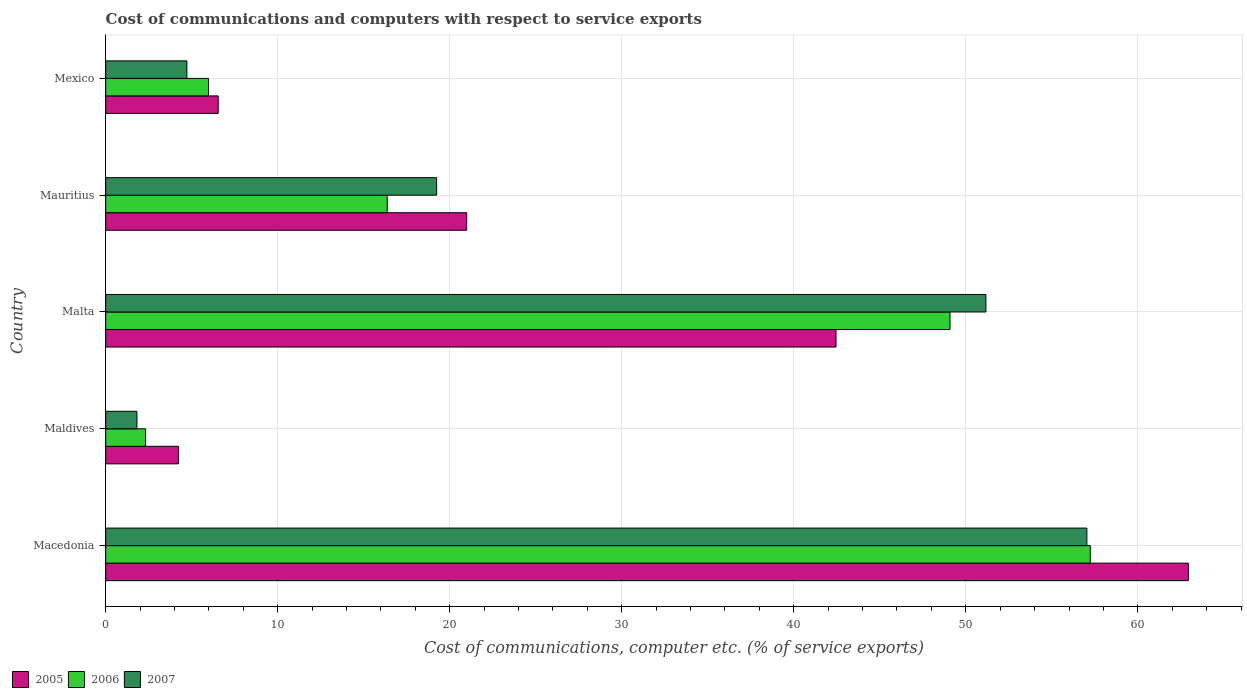How many different coloured bars are there?
Ensure brevity in your answer.  3. How many groups of bars are there?
Offer a very short reply. 5. Are the number of bars on each tick of the Y-axis equal?
Your answer should be very brief. Yes. How many bars are there on the 5th tick from the top?
Make the answer very short. 3. How many bars are there on the 1st tick from the bottom?
Offer a terse response. 3. What is the label of the 2nd group of bars from the top?
Offer a very short reply. Mauritius. In how many cases, is the number of bars for a given country not equal to the number of legend labels?
Make the answer very short. 0. What is the cost of communications and computers in 2006 in Malta?
Give a very brief answer. 49.08. Across all countries, what is the maximum cost of communications and computers in 2007?
Your answer should be very brief. 57.04. Across all countries, what is the minimum cost of communications and computers in 2006?
Your answer should be compact. 2.32. In which country was the cost of communications and computers in 2006 maximum?
Provide a short and direct response. Macedonia. In which country was the cost of communications and computers in 2007 minimum?
Offer a terse response. Maldives. What is the total cost of communications and computers in 2007 in the graph?
Offer a terse response. 133.98. What is the difference between the cost of communications and computers in 2007 in Macedonia and that in Maldives?
Provide a short and direct response. 55.22. What is the difference between the cost of communications and computers in 2007 in Maldives and the cost of communications and computers in 2006 in Mexico?
Your answer should be very brief. -4.16. What is the average cost of communications and computers in 2007 per country?
Your answer should be compact. 26.8. What is the difference between the cost of communications and computers in 2005 and cost of communications and computers in 2006 in Mauritius?
Provide a short and direct response. 4.62. In how many countries, is the cost of communications and computers in 2005 greater than 6 %?
Provide a short and direct response. 4. What is the ratio of the cost of communications and computers in 2007 in Malta to that in Mexico?
Your response must be concise. 10.84. What is the difference between the highest and the second highest cost of communications and computers in 2007?
Provide a short and direct response. 5.87. What is the difference between the highest and the lowest cost of communications and computers in 2005?
Offer a very short reply. 58.71. Is the sum of the cost of communications and computers in 2005 in Maldives and Mauritius greater than the maximum cost of communications and computers in 2007 across all countries?
Give a very brief answer. No. What does the 1st bar from the bottom in Macedonia represents?
Provide a succinct answer. 2005. Are all the bars in the graph horizontal?
Provide a succinct answer. Yes. Does the graph contain any zero values?
Offer a terse response. No. How many legend labels are there?
Your answer should be compact. 3. How are the legend labels stacked?
Provide a succinct answer. Horizontal. What is the title of the graph?
Provide a short and direct response. Cost of communications and computers with respect to service exports. What is the label or title of the X-axis?
Your answer should be compact. Cost of communications, computer etc. (% of service exports). What is the Cost of communications, computer etc. (% of service exports) in 2005 in Macedonia?
Offer a terse response. 62.94. What is the Cost of communications, computer etc. (% of service exports) in 2006 in Macedonia?
Provide a short and direct response. 57.24. What is the Cost of communications, computer etc. (% of service exports) of 2007 in Macedonia?
Offer a terse response. 57.04. What is the Cost of communications, computer etc. (% of service exports) of 2005 in Maldives?
Offer a very short reply. 4.23. What is the Cost of communications, computer etc. (% of service exports) of 2006 in Maldives?
Your response must be concise. 2.32. What is the Cost of communications, computer etc. (% of service exports) in 2007 in Maldives?
Give a very brief answer. 1.82. What is the Cost of communications, computer etc. (% of service exports) of 2005 in Malta?
Give a very brief answer. 42.46. What is the Cost of communications, computer etc. (% of service exports) in 2006 in Malta?
Offer a very short reply. 49.08. What is the Cost of communications, computer etc. (% of service exports) in 2007 in Malta?
Make the answer very short. 51.17. What is the Cost of communications, computer etc. (% of service exports) in 2005 in Mauritius?
Your response must be concise. 20.99. What is the Cost of communications, computer etc. (% of service exports) of 2006 in Mauritius?
Ensure brevity in your answer.  16.37. What is the Cost of communications, computer etc. (% of service exports) of 2007 in Mauritius?
Keep it short and to the point. 19.24. What is the Cost of communications, computer etc. (% of service exports) in 2005 in Mexico?
Provide a succinct answer. 6.54. What is the Cost of communications, computer etc. (% of service exports) of 2006 in Mexico?
Provide a succinct answer. 5.98. What is the Cost of communications, computer etc. (% of service exports) in 2007 in Mexico?
Offer a terse response. 4.72. Across all countries, what is the maximum Cost of communications, computer etc. (% of service exports) in 2005?
Your answer should be compact. 62.94. Across all countries, what is the maximum Cost of communications, computer etc. (% of service exports) of 2006?
Make the answer very short. 57.24. Across all countries, what is the maximum Cost of communications, computer etc. (% of service exports) of 2007?
Make the answer very short. 57.04. Across all countries, what is the minimum Cost of communications, computer etc. (% of service exports) of 2005?
Keep it short and to the point. 4.23. Across all countries, what is the minimum Cost of communications, computer etc. (% of service exports) of 2006?
Your answer should be very brief. 2.32. Across all countries, what is the minimum Cost of communications, computer etc. (% of service exports) in 2007?
Offer a terse response. 1.82. What is the total Cost of communications, computer etc. (% of service exports) of 2005 in the graph?
Your answer should be very brief. 137.15. What is the total Cost of communications, computer etc. (% of service exports) in 2006 in the graph?
Make the answer very short. 130.98. What is the total Cost of communications, computer etc. (% of service exports) of 2007 in the graph?
Give a very brief answer. 133.98. What is the difference between the Cost of communications, computer etc. (% of service exports) in 2005 in Macedonia and that in Maldives?
Offer a very short reply. 58.71. What is the difference between the Cost of communications, computer etc. (% of service exports) in 2006 in Macedonia and that in Maldives?
Provide a short and direct response. 54.92. What is the difference between the Cost of communications, computer etc. (% of service exports) in 2007 in Macedonia and that in Maldives?
Provide a short and direct response. 55.22. What is the difference between the Cost of communications, computer etc. (% of service exports) in 2005 in Macedonia and that in Malta?
Offer a very short reply. 20.48. What is the difference between the Cost of communications, computer etc. (% of service exports) in 2006 in Macedonia and that in Malta?
Give a very brief answer. 8.15. What is the difference between the Cost of communications, computer etc. (% of service exports) in 2007 in Macedonia and that in Malta?
Your answer should be compact. 5.87. What is the difference between the Cost of communications, computer etc. (% of service exports) in 2005 in Macedonia and that in Mauritius?
Keep it short and to the point. 41.95. What is the difference between the Cost of communications, computer etc. (% of service exports) of 2006 in Macedonia and that in Mauritius?
Offer a very short reply. 40.87. What is the difference between the Cost of communications, computer etc. (% of service exports) in 2007 in Macedonia and that in Mauritius?
Your answer should be compact. 37.8. What is the difference between the Cost of communications, computer etc. (% of service exports) of 2005 in Macedonia and that in Mexico?
Offer a very short reply. 56.4. What is the difference between the Cost of communications, computer etc. (% of service exports) of 2006 in Macedonia and that in Mexico?
Offer a very short reply. 51.26. What is the difference between the Cost of communications, computer etc. (% of service exports) of 2007 in Macedonia and that in Mexico?
Your response must be concise. 52.32. What is the difference between the Cost of communications, computer etc. (% of service exports) of 2005 in Maldives and that in Malta?
Offer a very short reply. -38.23. What is the difference between the Cost of communications, computer etc. (% of service exports) in 2006 in Maldives and that in Malta?
Offer a terse response. -46.77. What is the difference between the Cost of communications, computer etc. (% of service exports) of 2007 in Maldives and that in Malta?
Give a very brief answer. -49.35. What is the difference between the Cost of communications, computer etc. (% of service exports) of 2005 in Maldives and that in Mauritius?
Provide a succinct answer. -16.76. What is the difference between the Cost of communications, computer etc. (% of service exports) of 2006 in Maldives and that in Mauritius?
Provide a short and direct response. -14.05. What is the difference between the Cost of communications, computer etc. (% of service exports) in 2007 in Maldives and that in Mauritius?
Offer a very short reply. -17.42. What is the difference between the Cost of communications, computer etc. (% of service exports) of 2005 in Maldives and that in Mexico?
Ensure brevity in your answer.  -2.31. What is the difference between the Cost of communications, computer etc. (% of service exports) in 2006 in Maldives and that in Mexico?
Ensure brevity in your answer.  -3.66. What is the difference between the Cost of communications, computer etc. (% of service exports) of 2007 in Maldives and that in Mexico?
Your answer should be very brief. -2.9. What is the difference between the Cost of communications, computer etc. (% of service exports) in 2005 in Malta and that in Mauritius?
Give a very brief answer. 21.47. What is the difference between the Cost of communications, computer etc. (% of service exports) in 2006 in Malta and that in Mauritius?
Give a very brief answer. 32.72. What is the difference between the Cost of communications, computer etc. (% of service exports) in 2007 in Malta and that in Mauritius?
Your answer should be very brief. 31.93. What is the difference between the Cost of communications, computer etc. (% of service exports) in 2005 in Malta and that in Mexico?
Your response must be concise. 35.92. What is the difference between the Cost of communications, computer etc. (% of service exports) of 2006 in Malta and that in Mexico?
Give a very brief answer. 43.11. What is the difference between the Cost of communications, computer etc. (% of service exports) of 2007 in Malta and that in Mexico?
Provide a succinct answer. 46.45. What is the difference between the Cost of communications, computer etc. (% of service exports) in 2005 in Mauritius and that in Mexico?
Your answer should be compact. 14.45. What is the difference between the Cost of communications, computer etc. (% of service exports) of 2006 in Mauritius and that in Mexico?
Offer a very short reply. 10.39. What is the difference between the Cost of communications, computer etc. (% of service exports) in 2007 in Mauritius and that in Mexico?
Make the answer very short. 14.52. What is the difference between the Cost of communications, computer etc. (% of service exports) of 2005 in Macedonia and the Cost of communications, computer etc. (% of service exports) of 2006 in Maldives?
Provide a succinct answer. 60.62. What is the difference between the Cost of communications, computer etc. (% of service exports) in 2005 in Macedonia and the Cost of communications, computer etc. (% of service exports) in 2007 in Maldives?
Ensure brevity in your answer.  61.12. What is the difference between the Cost of communications, computer etc. (% of service exports) of 2006 in Macedonia and the Cost of communications, computer etc. (% of service exports) of 2007 in Maldives?
Ensure brevity in your answer.  55.42. What is the difference between the Cost of communications, computer etc. (% of service exports) of 2005 in Macedonia and the Cost of communications, computer etc. (% of service exports) of 2006 in Malta?
Your answer should be compact. 13.86. What is the difference between the Cost of communications, computer etc. (% of service exports) of 2005 in Macedonia and the Cost of communications, computer etc. (% of service exports) of 2007 in Malta?
Ensure brevity in your answer.  11.77. What is the difference between the Cost of communications, computer etc. (% of service exports) of 2006 in Macedonia and the Cost of communications, computer etc. (% of service exports) of 2007 in Malta?
Your answer should be very brief. 6.07. What is the difference between the Cost of communications, computer etc. (% of service exports) in 2005 in Macedonia and the Cost of communications, computer etc. (% of service exports) in 2006 in Mauritius?
Offer a very short reply. 46.57. What is the difference between the Cost of communications, computer etc. (% of service exports) in 2005 in Macedonia and the Cost of communications, computer etc. (% of service exports) in 2007 in Mauritius?
Provide a succinct answer. 43.7. What is the difference between the Cost of communications, computer etc. (% of service exports) of 2006 in Macedonia and the Cost of communications, computer etc. (% of service exports) of 2007 in Mauritius?
Make the answer very short. 38. What is the difference between the Cost of communications, computer etc. (% of service exports) in 2005 in Macedonia and the Cost of communications, computer etc. (% of service exports) in 2006 in Mexico?
Provide a short and direct response. 56.96. What is the difference between the Cost of communications, computer etc. (% of service exports) in 2005 in Macedonia and the Cost of communications, computer etc. (% of service exports) in 2007 in Mexico?
Make the answer very short. 58.22. What is the difference between the Cost of communications, computer etc. (% of service exports) of 2006 in Macedonia and the Cost of communications, computer etc. (% of service exports) of 2007 in Mexico?
Provide a short and direct response. 52.52. What is the difference between the Cost of communications, computer etc. (% of service exports) in 2005 in Maldives and the Cost of communications, computer etc. (% of service exports) in 2006 in Malta?
Your response must be concise. -44.85. What is the difference between the Cost of communications, computer etc. (% of service exports) in 2005 in Maldives and the Cost of communications, computer etc. (% of service exports) in 2007 in Malta?
Provide a succinct answer. -46.94. What is the difference between the Cost of communications, computer etc. (% of service exports) of 2006 in Maldives and the Cost of communications, computer etc. (% of service exports) of 2007 in Malta?
Your answer should be very brief. -48.85. What is the difference between the Cost of communications, computer etc. (% of service exports) of 2005 in Maldives and the Cost of communications, computer etc. (% of service exports) of 2006 in Mauritius?
Offer a very short reply. -12.14. What is the difference between the Cost of communications, computer etc. (% of service exports) of 2005 in Maldives and the Cost of communications, computer etc. (% of service exports) of 2007 in Mauritius?
Keep it short and to the point. -15.01. What is the difference between the Cost of communications, computer etc. (% of service exports) in 2006 in Maldives and the Cost of communications, computer etc. (% of service exports) in 2007 in Mauritius?
Provide a succinct answer. -16.92. What is the difference between the Cost of communications, computer etc. (% of service exports) of 2005 in Maldives and the Cost of communications, computer etc. (% of service exports) of 2006 in Mexico?
Your answer should be very brief. -1.75. What is the difference between the Cost of communications, computer etc. (% of service exports) of 2005 in Maldives and the Cost of communications, computer etc. (% of service exports) of 2007 in Mexico?
Make the answer very short. -0.49. What is the difference between the Cost of communications, computer etc. (% of service exports) in 2006 in Maldives and the Cost of communications, computer etc. (% of service exports) in 2007 in Mexico?
Keep it short and to the point. -2.4. What is the difference between the Cost of communications, computer etc. (% of service exports) of 2005 in Malta and the Cost of communications, computer etc. (% of service exports) of 2006 in Mauritius?
Keep it short and to the point. 26.09. What is the difference between the Cost of communications, computer etc. (% of service exports) in 2005 in Malta and the Cost of communications, computer etc. (% of service exports) in 2007 in Mauritius?
Make the answer very short. 23.22. What is the difference between the Cost of communications, computer etc. (% of service exports) in 2006 in Malta and the Cost of communications, computer etc. (% of service exports) in 2007 in Mauritius?
Your answer should be compact. 29.84. What is the difference between the Cost of communications, computer etc. (% of service exports) in 2005 in Malta and the Cost of communications, computer etc. (% of service exports) in 2006 in Mexico?
Ensure brevity in your answer.  36.48. What is the difference between the Cost of communications, computer etc. (% of service exports) in 2005 in Malta and the Cost of communications, computer etc. (% of service exports) in 2007 in Mexico?
Ensure brevity in your answer.  37.74. What is the difference between the Cost of communications, computer etc. (% of service exports) of 2006 in Malta and the Cost of communications, computer etc. (% of service exports) of 2007 in Mexico?
Keep it short and to the point. 44.36. What is the difference between the Cost of communications, computer etc. (% of service exports) in 2005 in Mauritius and the Cost of communications, computer etc. (% of service exports) in 2006 in Mexico?
Give a very brief answer. 15.01. What is the difference between the Cost of communications, computer etc. (% of service exports) of 2005 in Mauritius and the Cost of communications, computer etc. (% of service exports) of 2007 in Mexico?
Your response must be concise. 16.27. What is the difference between the Cost of communications, computer etc. (% of service exports) in 2006 in Mauritius and the Cost of communications, computer etc. (% of service exports) in 2007 in Mexico?
Offer a terse response. 11.65. What is the average Cost of communications, computer etc. (% of service exports) of 2005 per country?
Your answer should be very brief. 27.43. What is the average Cost of communications, computer etc. (% of service exports) of 2006 per country?
Your answer should be very brief. 26.2. What is the average Cost of communications, computer etc. (% of service exports) in 2007 per country?
Your response must be concise. 26.8. What is the difference between the Cost of communications, computer etc. (% of service exports) of 2005 and Cost of communications, computer etc. (% of service exports) of 2006 in Macedonia?
Provide a short and direct response. 5.7. What is the difference between the Cost of communications, computer etc. (% of service exports) in 2005 and Cost of communications, computer etc. (% of service exports) in 2007 in Macedonia?
Your response must be concise. 5.9. What is the difference between the Cost of communications, computer etc. (% of service exports) in 2006 and Cost of communications, computer etc. (% of service exports) in 2007 in Macedonia?
Offer a very short reply. 0.2. What is the difference between the Cost of communications, computer etc. (% of service exports) in 2005 and Cost of communications, computer etc. (% of service exports) in 2006 in Maldives?
Your response must be concise. 1.91. What is the difference between the Cost of communications, computer etc. (% of service exports) in 2005 and Cost of communications, computer etc. (% of service exports) in 2007 in Maldives?
Provide a short and direct response. 2.41. What is the difference between the Cost of communications, computer etc. (% of service exports) of 2006 and Cost of communications, computer etc. (% of service exports) of 2007 in Maldives?
Your response must be concise. 0.5. What is the difference between the Cost of communications, computer etc. (% of service exports) of 2005 and Cost of communications, computer etc. (% of service exports) of 2006 in Malta?
Offer a terse response. -6.63. What is the difference between the Cost of communications, computer etc. (% of service exports) of 2005 and Cost of communications, computer etc. (% of service exports) of 2007 in Malta?
Give a very brief answer. -8.71. What is the difference between the Cost of communications, computer etc. (% of service exports) in 2006 and Cost of communications, computer etc. (% of service exports) in 2007 in Malta?
Make the answer very short. -2.09. What is the difference between the Cost of communications, computer etc. (% of service exports) of 2005 and Cost of communications, computer etc. (% of service exports) of 2006 in Mauritius?
Keep it short and to the point. 4.62. What is the difference between the Cost of communications, computer etc. (% of service exports) of 2005 and Cost of communications, computer etc. (% of service exports) of 2007 in Mauritius?
Offer a terse response. 1.75. What is the difference between the Cost of communications, computer etc. (% of service exports) of 2006 and Cost of communications, computer etc. (% of service exports) of 2007 in Mauritius?
Give a very brief answer. -2.87. What is the difference between the Cost of communications, computer etc. (% of service exports) in 2005 and Cost of communications, computer etc. (% of service exports) in 2006 in Mexico?
Offer a terse response. 0.56. What is the difference between the Cost of communications, computer etc. (% of service exports) in 2005 and Cost of communications, computer etc. (% of service exports) in 2007 in Mexico?
Give a very brief answer. 1.82. What is the difference between the Cost of communications, computer etc. (% of service exports) of 2006 and Cost of communications, computer etc. (% of service exports) of 2007 in Mexico?
Provide a succinct answer. 1.26. What is the ratio of the Cost of communications, computer etc. (% of service exports) in 2005 in Macedonia to that in Maldives?
Your answer should be very brief. 14.89. What is the ratio of the Cost of communications, computer etc. (% of service exports) of 2006 in Macedonia to that in Maldives?
Provide a succinct answer. 24.72. What is the ratio of the Cost of communications, computer etc. (% of service exports) in 2007 in Macedonia to that in Maldives?
Provide a succinct answer. 31.38. What is the ratio of the Cost of communications, computer etc. (% of service exports) of 2005 in Macedonia to that in Malta?
Your response must be concise. 1.48. What is the ratio of the Cost of communications, computer etc. (% of service exports) in 2006 in Macedonia to that in Malta?
Provide a short and direct response. 1.17. What is the ratio of the Cost of communications, computer etc. (% of service exports) in 2007 in Macedonia to that in Malta?
Give a very brief answer. 1.11. What is the ratio of the Cost of communications, computer etc. (% of service exports) of 2005 in Macedonia to that in Mauritius?
Offer a very short reply. 3. What is the ratio of the Cost of communications, computer etc. (% of service exports) of 2006 in Macedonia to that in Mauritius?
Offer a terse response. 3.5. What is the ratio of the Cost of communications, computer etc. (% of service exports) in 2007 in Macedonia to that in Mauritius?
Ensure brevity in your answer.  2.96. What is the ratio of the Cost of communications, computer etc. (% of service exports) of 2005 in Macedonia to that in Mexico?
Provide a succinct answer. 9.62. What is the ratio of the Cost of communications, computer etc. (% of service exports) in 2006 in Macedonia to that in Mexico?
Ensure brevity in your answer.  9.58. What is the ratio of the Cost of communications, computer etc. (% of service exports) in 2007 in Macedonia to that in Mexico?
Offer a very short reply. 12.09. What is the ratio of the Cost of communications, computer etc. (% of service exports) of 2005 in Maldives to that in Malta?
Your answer should be compact. 0.1. What is the ratio of the Cost of communications, computer etc. (% of service exports) of 2006 in Maldives to that in Malta?
Ensure brevity in your answer.  0.05. What is the ratio of the Cost of communications, computer etc. (% of service exports) in 2007 in Maldives to that in Malta?
Ensure brevity in your answer.  0.04. What is the ratio of the Cost of communications, computer etc. (% of service exports) in 2005 in Maldives to that in Mauritius?
Your response must be concise. 0.2. What is the ratio of the Cost of communications, computer etc. (% of service exports) of 2006 in Maldives to that in Mauritius?
Give a very brief answer. 0.14. What is the ratio of the Cost of communications, computer etc. (% of service exports) in 2007 in Maldives to that in Mauritius?
Your answer should be compact. 0.09. What is the ratio of the Cost of communications, computer etc. (% of service exports) in 2005 in Maldives to that in Mexico?
Provide a short and direct response. 0.65. What is the ratio of the Cost of communications, computer etc. (% of service exports) of 2006 in Maldives to that in Mexico?
Offer a terse response. 0.39. What is the ratio of the Cost of communications, computer etc. (% of service exports) in 2007 in Maldives to that in Mexico?
Provide a short and direct response. 0.39. What is the ratio of the Cost of communications, computer etc. (% of service exports) in 2005 in Malta to that in Mauritius?
Your answer should be very brief. 2.02. What is the ratio of the Cost of communications, computer etc. (% of service exports) in 2006 in Malta to that in Mauritius?
Make the answer very short. 3. What is the ratio of the Cost of communications, computer etc. (% of service exports) of 2007 in Malta to that in Mauritius?
Your response must be concise. 2.66. What is the ratio of the Cost of communications, computer etc. (% of service exports) in 2005 in Malta to that in Mexico?
Provide a short and direct response. 6.49. What is the ratio of the Cost of communications, computer etc. (% of service exports) of 2006 in Malta to that in Mexico?
Give a very brief answer. 8.21. What is the ratio of the Cost of communications, computer etc. (% of service exports) of 2007 in Malta to that in Mexico?
Provide a succinct answer. 10.84. What is the ratio of the Cost of communications, computer etc. (% of service exports) of 2005 in Mauritius to that in Mexico?
Provide a succinct answer. 3.21. What is the ratio of the Cost of communications, computer etc. (% of service exports) of 2006 in Mauritius to that in Mexico?
Make the answer very short. 2.74. What is the ratio of the Cost of communications, computer etc. (% of service exports) of 2007 in Mauritius to that in Mexico?
Give a very brief answer. 4.08. What is the difference between the highest and the second highest Cost of communications, computer etc. (% of service exports) of 2005?
Your answer should be very brief. 20.48. What is the difference between the highest and the second highest Cost of communications, computer etc. (% of service exports) of 2006?
Your answer should be very brief. 8.15. What is the difference between the highest and the second highest Cost of communications, computer etc. (% of service exports) in 2007?
Your answer should be very brief. 5.87. What is the difference between the highest and the lowest Cost of communications, computer etc. (% of service exports) of 2005?
Your answer should be compact. 58.71. What is the difference between the highest and the lowest Cost of communications, computer etc. (% of service exports) in 2006?
Offer a very short reply. 54.92. What is the difference between the highest and the lowest Cost of communications, computer etc. (% of service exports) of 2007?
Your answer should be compact. 55.22. 